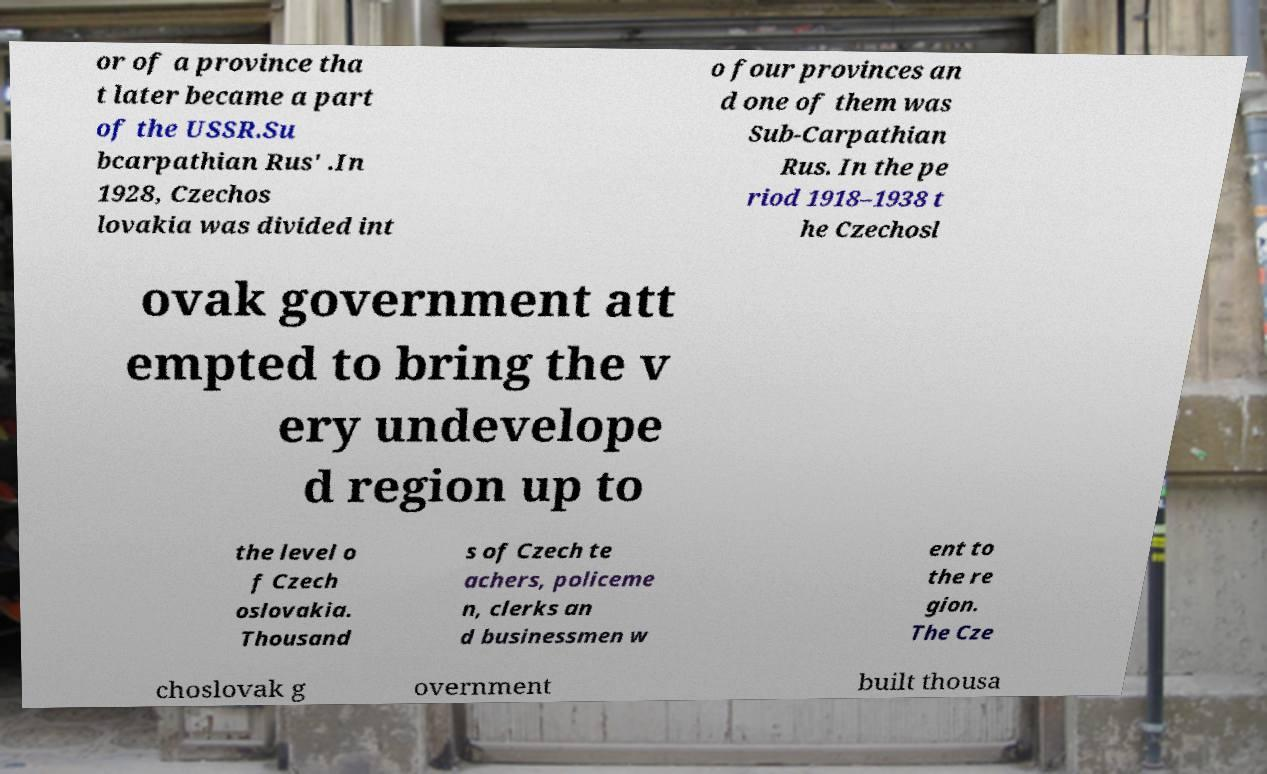Could you assist in decoding the text presented in this image and type it out clearly? or of a province tha t later became a part of the USSR.Su bcarpathian Rus' .In 1928, Czechos lovakia was divided int o four provinces an d one of them was Sub-Carpathian Rus. In the pe riod 1918–1938 t he Czechosl ovak government att empted to bring the v ery undevelope d region up to the level o f Czech oslovakia. Thousand s of Czech te achers, policeme n, clerks an d businessmen w ent to the re gion. The Cze choslovak g overnment built thousa 